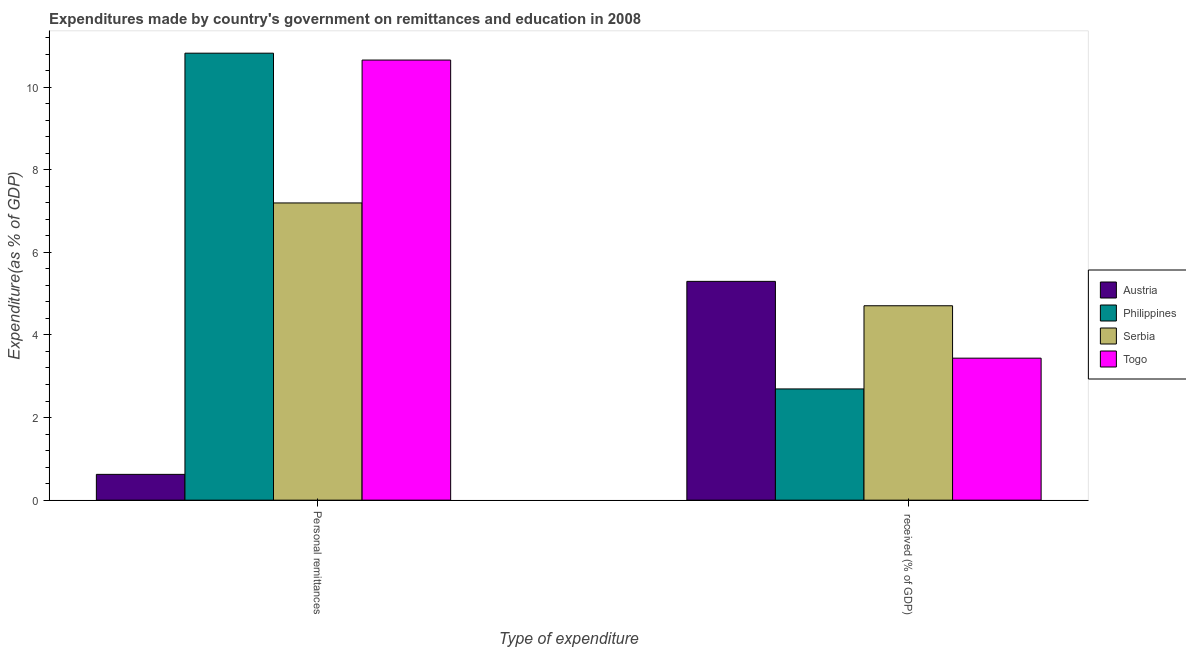How many groups of bars are there?
Keep it short and to the point. 2. Are the number of bars per tick equal to the number of legend labels?
Your response must be concise. Yes. What is the label of the 2nd group of bars from the left?
Keep it short and to the point.  received (% of GDP). What is the expenditure in personal remittances in Philippines?
Your answer should be compact. 10.82. Across all countries, what is the maximum expenditure in education?
Provide a short and direct response. 5.3. Across all countries, what is the minimum expenditure in education?
Provide a short and direct response. 2.69. In which country was the expenditure in personal remittances maximum?
Keep it short and to the point. Philippines. In which country was the expenditure in education minimum?
Your answer should be compact. Philippines. What is the total expenditure in personal remittances in the graph?
Your answer should be compact. 29.3. What is the difference between the expenditure in education in Serbia and that in Togo?
Your response must be concise. 1.27. What is the difference between the expenditure in education in Serbia and the expenditure in personal remittances in Austria?
Offer a very short reply. 4.08. What is the average expenditure in personal remittances per country?
Offer a very short reply. 7.32. What is the difference between the expenditure in education and expenditure in personal remittances in Austria?
Provide a short and direct response. 4.67. In how many countries, is the expenditure in education greater than 3.6 %?
Your answer should be compact. 2. What is the ratio of the expenditure in personal remittances in Austria to that in Philippines?
Ensure brevity in your answer.  0.06. Is the expenditure in education in Serbia less than that in Togo?
Your response must be concise. No. In how many countries, is the expenditure in education greater than the average expenditure in education taken over all countries?
Your answer should be very brief. 2. What does the 3rd bar from the left in  received (% of GDP) represents?
Your response must be concise. Serbia. What does the 4th bar from the right in  received (% of GDP) represents?
Ensure brevity in your answer.  Austria. How many bars are there?
Provide a succinct answer. 8. How many countries are there in the graph?
Your answer should be compact. 4. Are the values on the major ticks of Y-axis written in scientific E-notation?
Your response must be concise. No. Does the graph contain any zero values?
Offer a very short reply. No. Does the graph contain grids?
Keep it short and to the point. No. Where does the legend appear in the graph?
Provide a short and direct response. Center right. What is the title of the graph?
Give a very brief answer. Expenditures made by country's government on remittances and education in 2008. What is the label or title of the X-axis?
Ensure brevity in your answer.  Type of expenditure. What is the label or title of the Y-axis?
Offer a terse response. Expenditure(as % of GDP). What is the Expenditure(as % of GDP) of Austria in Personal remittances?
Your answer should be very brief. 0.62. What is the Expenditure(as % of GDP) of Philippines in Personal remittances?
Provide a short and direct response. 10.82. What is the Expenditure(as % of GDP) of Serbia in Personal remittances?
Provide a short and direct response. 7.2. What is the Expenditure(as % of GDP) in Togo in Personal remittances?
Offer a terse response. 10.65. What is the Expenditure(as % of GDP) of Austria in  received (% of GDP)?
Make the answer very short. 5.3. What is the Expenditure(as % of GDP) of Philippines in  received (% of GDP)?
Provide a short and direct response. 2.69. What is the Expenditure(as % of GDP) in Serbia in  received (% of GDP)?
Provide a short and direct response. 4.71. What is the Expenditure(as % of GDP) in Togo in  received (% of GDP)?
Ensure brevity in your answer.  3.44. Across all Type of expenditure, what is the maximum Expenditure(as % of GDP) in Austria?
Offer a very short reply. 5.3. Across all Type of expenditure, what is the maximum Expenditure(as % of GDP) in Philippines?
Offer a very short reply. 10.82. Across all Type of expenditure, what is the maximum Expenditure(as % of GDP) in Serbia?
Provide a short and direct response. 7.2. Across all Type of expenditure, what is the maximum Expenditure(as % of GDP) in Togo?
Your answer should be very brief. 10.65. Across all Type of expenditure, what is the minimum Expenditure(as % of GDP) in Austria?
Keep it short and to the point. 0.62. Across all Type of expenditure, what is the minimum Expenditure(as % of GDP) of Philippines?
Your response must be concise. 2.69. Across all Type of expenditure, what is the minimum Expenditure(as % of GDP) of Serbia?
Your answer should be very brief. 4.71. Across all Type of expenditure, what is the minimum Expenditure(as % of GDP) in Togo?
Offer a terse response. 3.44. What is the total Expenditure(as % of GDP) of Austria in the graph?
Offer a very short reply. 5.92. What is the total Expenditure(as % of GDP) in Philippines in the graph?
Make the answer very short. 13.51. What is the total Expenditure(as % of GDP) in Serbia in the graph?
Ensure brevity in your answer.  11.9. What is the total Expenditure(as % of GDP) in Togo in the graph?
Provide a succinct answer. 14.09. What is the difference between the Expenditure(as % of GDP) of Austria in Personal remittances and that in  received (% of GDP)?
Your answer should be compact. -4.67. What is the difference between the Expenditure(as % of GDP) in Philippines in Personal remittances and that in  received (% of GDP)?
Your response must be concise. 8.13. What is the difference between the Expenditure(as % of GDP) in Serbia in Personal remittances and that in  received (% of GDP)?
Ensure brevity in your answer.  2.49. What is the difference between the Expenditure(as % of GDP) of Togo in Personal remittances and that in  received (% of GDP)?
Offer a very short reply. 7.22. What is the difference between the Expenditure(as % of GDP) in Austria in Personal remittances and the Expenditure(as % of GDP) in Philippines in  received (% of GDP)?
Make the answer very short. -2.07. What is the difference between the Expenditure(as % of GDP) in Austria in Personal remittances and the Expenditure(as % of GDP) in Serbia in  received (% of GDP)?
Offer a very short reply. -4.08. What is the difference between the Expenditure(as % of GDP) in Austria in Personal remittances and the Expenditure(as % of GDP) in Togo in  received (% of GDP)?
Provide a short and direct response. -2.81. What is the difference between the Expenditure(as % of GDP) in Philippines in Personal remittances and the Expenditure(as % of GDP) in Serbia in  received (% of GDP)?
Give a very brief answer. 6.12. What is the difference between the Expenditure(as % of GDP) in Philippines in Personal remittances and the Expenditure(as % of GDP) in Togo in  received (% of GDP)?
Provide a succinct answer. 7.38. What is the difference between the Expenditure(as % of GDP) of Serbia in Personal remittances and the Expenditure(as % of GDP) of Togo in  received (% of GDP)?
Offer a very short reply. 3.76. What is the average Expenditure(as % of GDP) in Austria per Type of expenditure?
Your response must be concise. 2.96. What is the average Expenditure(as % of GDP) of Philippines per Type of expenditure?
Give a very brief answer. 6.76. What is the average Expenditure(as % of GDP) in Serbia per Type of expenditure?
Give a very brief answer. 5.95. What is the average Expenditure(as % of GDP) in Togo per Type of expenditure?
Offer a terse response. 7.05. What is the difference between the Expenditure(as % of GDP) of Austria and Expenditure(as % of GDP) of Philippines in Personal remittances?
Offer a very short reply. -10.2. What is the difference between the Expenditure(as % of GDP) of Austria and Expenditure(as % of GDP) of Serbia in Personal remittances?
Keep it short and to the point. -6.57. What is the difference between the Expenditure(as % of GDP) of Austria and Expenditure(as % of GDP) of Togo in Personal remittances?
Your answer should be compact. -10.03. What is the difference between the Expenditure(as % of GDP) in Philippines and Expenditure(as % of GDP) in Serbia in Personal remittances?
Provide a succinct answer. 3.63. What is the difference between the Expenditure(as % of GDP) of Serbia and Expenditure(as % of GDP) of Togo in Personal remittances?
Give a very brief answer. -3.46. What is the difference between the Expenditure(as % of GDP) in Austria and Expenditure(as % of GDP) in Philippines in  received (% of GDP)?
Give a very brief answer. 2.6. What is the difference between the Expenditure(as % of GDP) of Austria and Expenditure(as % of GDP) of Serbia in  received (% of GDP)?
Your answer should be very brief. 0.59. What is the difference between the Expenditure(as % of GDP) in Austria and Expenditure(as % of GDP) in Togo in  received (% of GDP)?
Offer a terse response. 1.86. What is the difference between the Expenditure(as % of GDP) of Philippines and Expenditure(as % of GDP) of Serbia in  received (% of GDP)?
Offer a terse response. -2.01. What is the difference between the Expenditure(as % of GDP) of Philippines and Expenditure(as % of GDP) of Togo in  received (% of GDP)?
Provide a short and direct response. -0.74. What is the difference between the Expenditure(as % of GDP) in Serbia and Expenditure(as % of GDP) in Togo in  received (% of GDP)?
Your response must be concise. 1.27. What is the ratio of the Expenditure(as % of GDP) in Austria in Personal remittances to that in  received (% of GDP)?
Your response must be concise. 0.12. What is the ratio of the Expenditure(as % of GDP) of Philippines in Personal remittances to that in  received (% of GDP)?
Make the answer very short. 4.02. What is the ratio of the Expenditure(as % of GDP) in Serbia in Personal remittances to that in  received (% of GDP)?
Your answer should be very brief. 1.53. What is the ratio of the Expenditure(as % of GDP) of Togo in Personal remittances to that in  received (% of GDP)?
Keep it short and to the point. 3.1. What is the difference between the highest and the second highest Expenditure(as % of GDP) in Austria?
Your response must be concise. 4.67. What is the difference between the highest and the second highest Expenditure(as % of GDP) of Philippines?
Your answer should be compact. 8.13. What is the difference between the highest and the second highest Expenditure(as % of GDP) of Serbia?
Ensure brevity in your answer.  2.49. What is the difference between the highest and the second highest Expenditure(as % of GDP) in Togo?
Your response must be concise. 7.22. What is the difference between the highest and the lowest Expenditure(as % of GDP) of Austria?
Offer a terse response. 4.67. What is the difference between the highest and the lowest Expenditure(as % of GDP) of Philippines?
Keep it short and to the point. 8.13. What is the difference between the highest and the lowest Expenditure(as % of GDP) in Serbia?
Provide a succinct answer. 2.49. What is the difference between the highest and the lowest Expenditure(as % of GDP) of Togo?
Your answer should be compact. 7.22. 